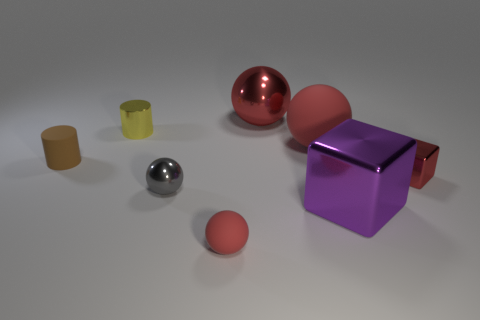How many red balls must be subtracted to get 1 red balls? 2 Add 1 big matte objects. How many objects exist? 9 Subtract all gray spheres. How many spheres are left? 3 Subtract all cubes. How many objects are left? 6 Subtract 2 spheres. How many spheres are left? 2 Subtract all purple cubes. Subtract all yellow cylinders. How many cubes are left? 1 Subtract all purple spheres. How many purple blocks are left? 1 Subtract all big blue metallic cubes. Subtract all yellow metal things. How many objects are left? 7 Add 2 small spheres. How many small spheres are left? 4 Add 7 large spheres. How many large spheres exist? 9 